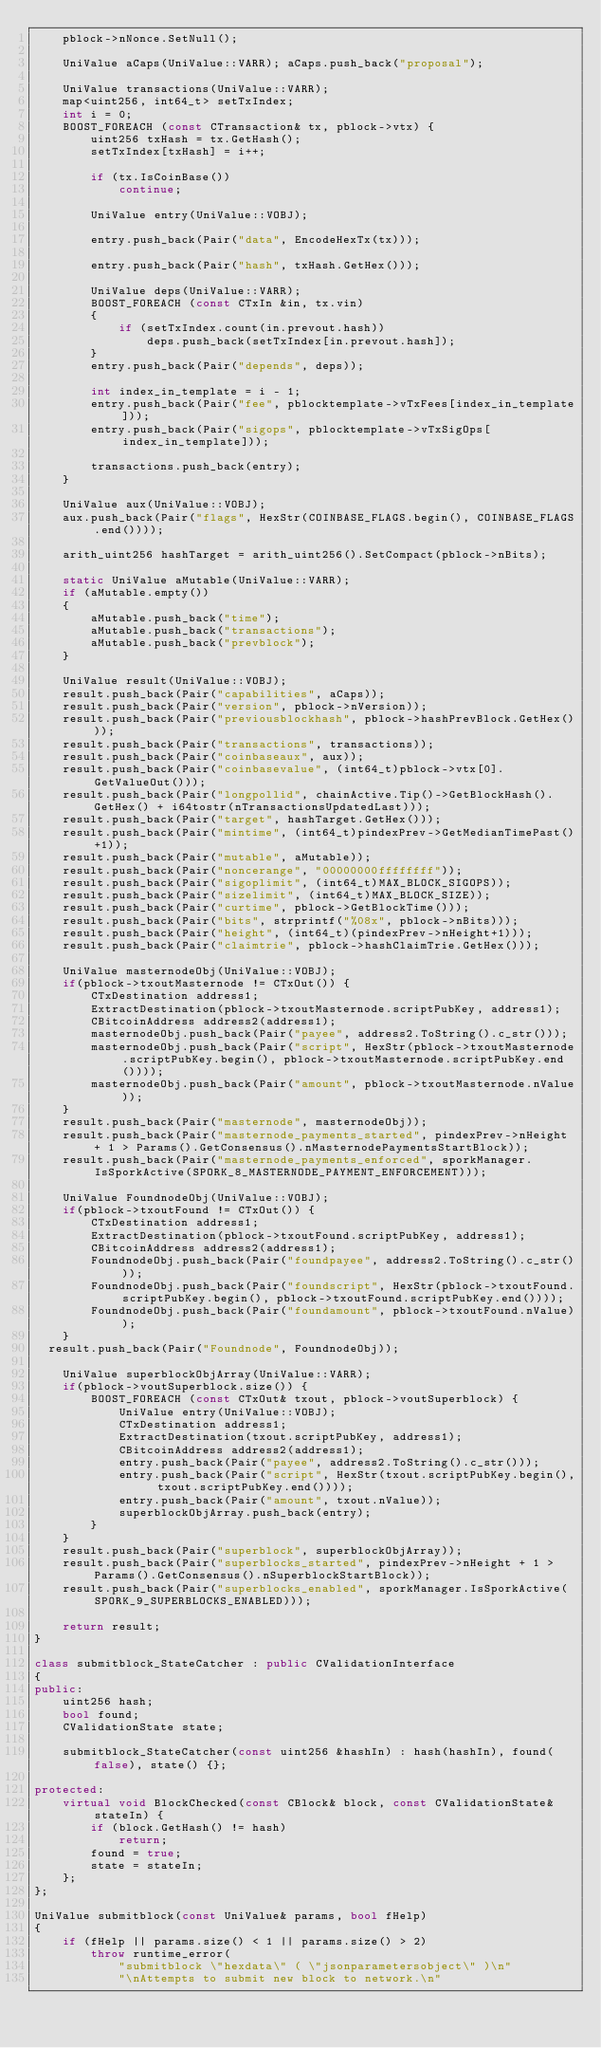<code> <loc_0><loc_0><loc_500><loc_500><_C++_>    pblock->nNonce.SetNull();

    UniValue aCaps(UniValue::VARR); aCaps.push_back("proposal");

    UniValue transactions(UniValue::VARR);
    map<uint256, int64_t> setTxIndex;
    int i = 0;
    BOOST_FOREACH (const CTransaction& tx, pblock->vtx) {
        uint256 txHash = tx.GetHash();
        setTxIndex[txHash] = i++;

        if (tx.IsCoinBase())
            continue;

        UniValue entry(UniValue::VOBJ);

        entry.push_back(Pair("data", EncodeHexTx(tx)));

        entry.push_back(Pair("hash", txHash.GetHex()));

        UniValue deps(UniValue::VARR);
        BOOST_FOREACH (const CTxIn &in, tx.vin)
        {
            if (setTxIndex.count(in.prevout.hash))
                deps.push_back(setTxIndex[in.prevout.hash]);
        }
        entry.push_back(Pair("depends", deps));

        int index_in_template = i - 1;
        entry.push_back(Pair("fee", pblocktemplate->vTxFees[index_in_template]));
        entry.push_back(Pair("sigops", pblocktemplate->vTxSigOps[index_in_template]));

        transactions.push_back(entry);
    }

    UniValue aux(UniValue::VOBJ);
    aux.push_back(Pair("flags", HexStr(COINBASE_FLAGS.begin(), COINBASE_FLAGS.end())));

    arith_uint256 hashTarget = arith_uint256().SetCompact(pblock->nBits);

    static UniValue aMutable(UniValue::VARR);
    if (aMutable.empty())
    {
        aMutable.push_back("time");
        aMutable.push_back("transactions");
        aMutable.push_back("prevblock");
    }

    UniValue result(UniValue::VOBJ);
    result.push_back(Pair("capabilities", aCaps));
    result.push_back(Pair("version", pblock->nVersion));
    result.push_back(Pair("previousblockhash", pblock->hashPrevBlock.GetHex()));
    result.push_back(Pair("transactions", transactions));
    result.push_back(Pair("coinbaseaux", aux));
    result.push_back(Pair("coinbasevalue", (int64_t)pblock->vtx[0].GetValueOut()));
    result.push_back(Pair("longpollid", chainActive.Tip()->GetBlockHash().GetHex() + i64tostr(nTransactionsUpdatedLast)));
    result.push_back(Pair("target", hashTarget.GetHex()));
    result.push_back(Pair("mintime", (int64_t)pindexPrev->GetMedianTimePast()+1));
    result.push_back(Pair("mutable", aMutable));
    result.push_back(Pair("noncerange", "00000000ffffffff"));
    result.push_back(Pair("sigoplimit", (int64_t)MAX_BLOCK_SIGOPS));
    result.push_back(Pair("sizelimit", (int64_t)MAX_BLOCK_SIZE));
    result.push_back(Pair("curtime", pblock->GetBlockTime()));
    result.push_back(Pair("bits", strprintf("%08x", pblock->nBits)));
    result.push_back(Pair("height", (int64_t)(pindexPrev->nHeight+1)));
    result.push_back(Pair("claimtrie", pblock->hashClaimTrie.GetHex()));

    UniValue masternodeObj(UniValue::VOBJ);
    if(pblock->txoutMasternode != CTxOut()) {
        CTxDestination address1;
        ExtractDestination(pblock->txoutMasternode.scriptPubKey, address1);
        CBitcoinAddress address2(address1);
        masternodeObj.push_back(Pair("payee", address2.ToString().c_str()));
        masternodeObj.push_back(Pair("script", HexStr(pblock->txoutMasternode.scriptPubKey.begin(), pblock->txoutMasternode.scriptPubKey.end())));
        masternodeObj.push_back(Pair("amount", pblock->txoutMasternode.nValue));
    }
    result.push_back(Pair("masternode", masternodeObj));
    result.push_back(Pair("masternode_payments_started", pindexPrev->nHeight + 1 > Params().GetConsensus().nMasternodePaymentsStartBlock));
    result.push_back(Pair("masternode_payments_enforced", sporkManager.IsSporkActive(SPORK_8_MASTERNODE_PAYMENT_ENFORCEMENT)));

    UniValue FoundnodeObj(UniValue::VOBJ);
    if(pblock->txoutFound != CTxOut()) {
        CTxDestination address1;
        ExtractDestination(pblock->txoutFound.scriptPubKey, address1);
        CBitcoinAddress address2(address1);
        FoundnodeObj.push_back(Pair("foundpayee", address2.ToString().c_str()));
        FoundnodeObj.push_back(Pair("foundscript", HexStr(pblock->txoutFound.scriptPubKey.begin(), pblock->txoutFound.scriptPubKey.end())));
        FoundnodeObj.push_back(Pair("foundamount", pblock->txoutFound.nValue));
    }	
	result.push_back(Pair("Foundnode", FoundnodeObj));

    UniValue superblockObjArray(UniValue::VARR);
    if(pblock->voutSuperblock.size()) {
        BOOST_FOREACH (const CTxOut& txout, pblock->voutSuperblock) {
            UniValue entry(UniValue::VOBJ);
            CTxDestination address1;
            ExtractDestination(txout.scriptPubKey, address1);
            CBitcoinAddress address2(address1);
            entry.push_back(Pair("payee", address2.ToString().c_str()));
            entry.push_back(Pair("script", HexStr(txout.scriptPubKey.begin(), txout.scriptPubKey.end())));
            entry.push_back(Pair("amount", txout.nValue));
            superblockObjArray.push_back(entry);
        }
    }
    result.push_back(Pair("superblock", superblockObjArray));
    result.push_back(Pair("superblocks_started", pindexPrev->nHeight + 1 > Params().GetConsensus().nSuperblockStartBlock));
    result.push_back(Pair("superblocks_enabled", sporkManager.IsSporkActive(SPORK_9_SUPERBLOCKS_ENABLED)));

    return result;
}

class submitblock_StateCatcher : public CValidationInterface
{
public:
    uint256 hash;
    bool found;
    CValidationState state;

    submitblock_StateCatcher(const uint256 &hashIn) : hash(hashIn), found(false), state() {};

protected:
    virtual void BlockChecked(const CBlock& block, const CValidationState& stateIn) {
        if (block.GetHash() != hash)
            return;
        found = true;
        state = stateIn;
    };
};

UniValue submitblock(const UniValue& params, bool fHelp)
{
    if (fHelp || params.size() < 1 || params.size() > 2)
        throw runtime_error(
            "submitblock \"hexdata\" ( \"jsonparametersobject\" )\n"
            "\nAttempts to submit new block to network.\n"</code> 